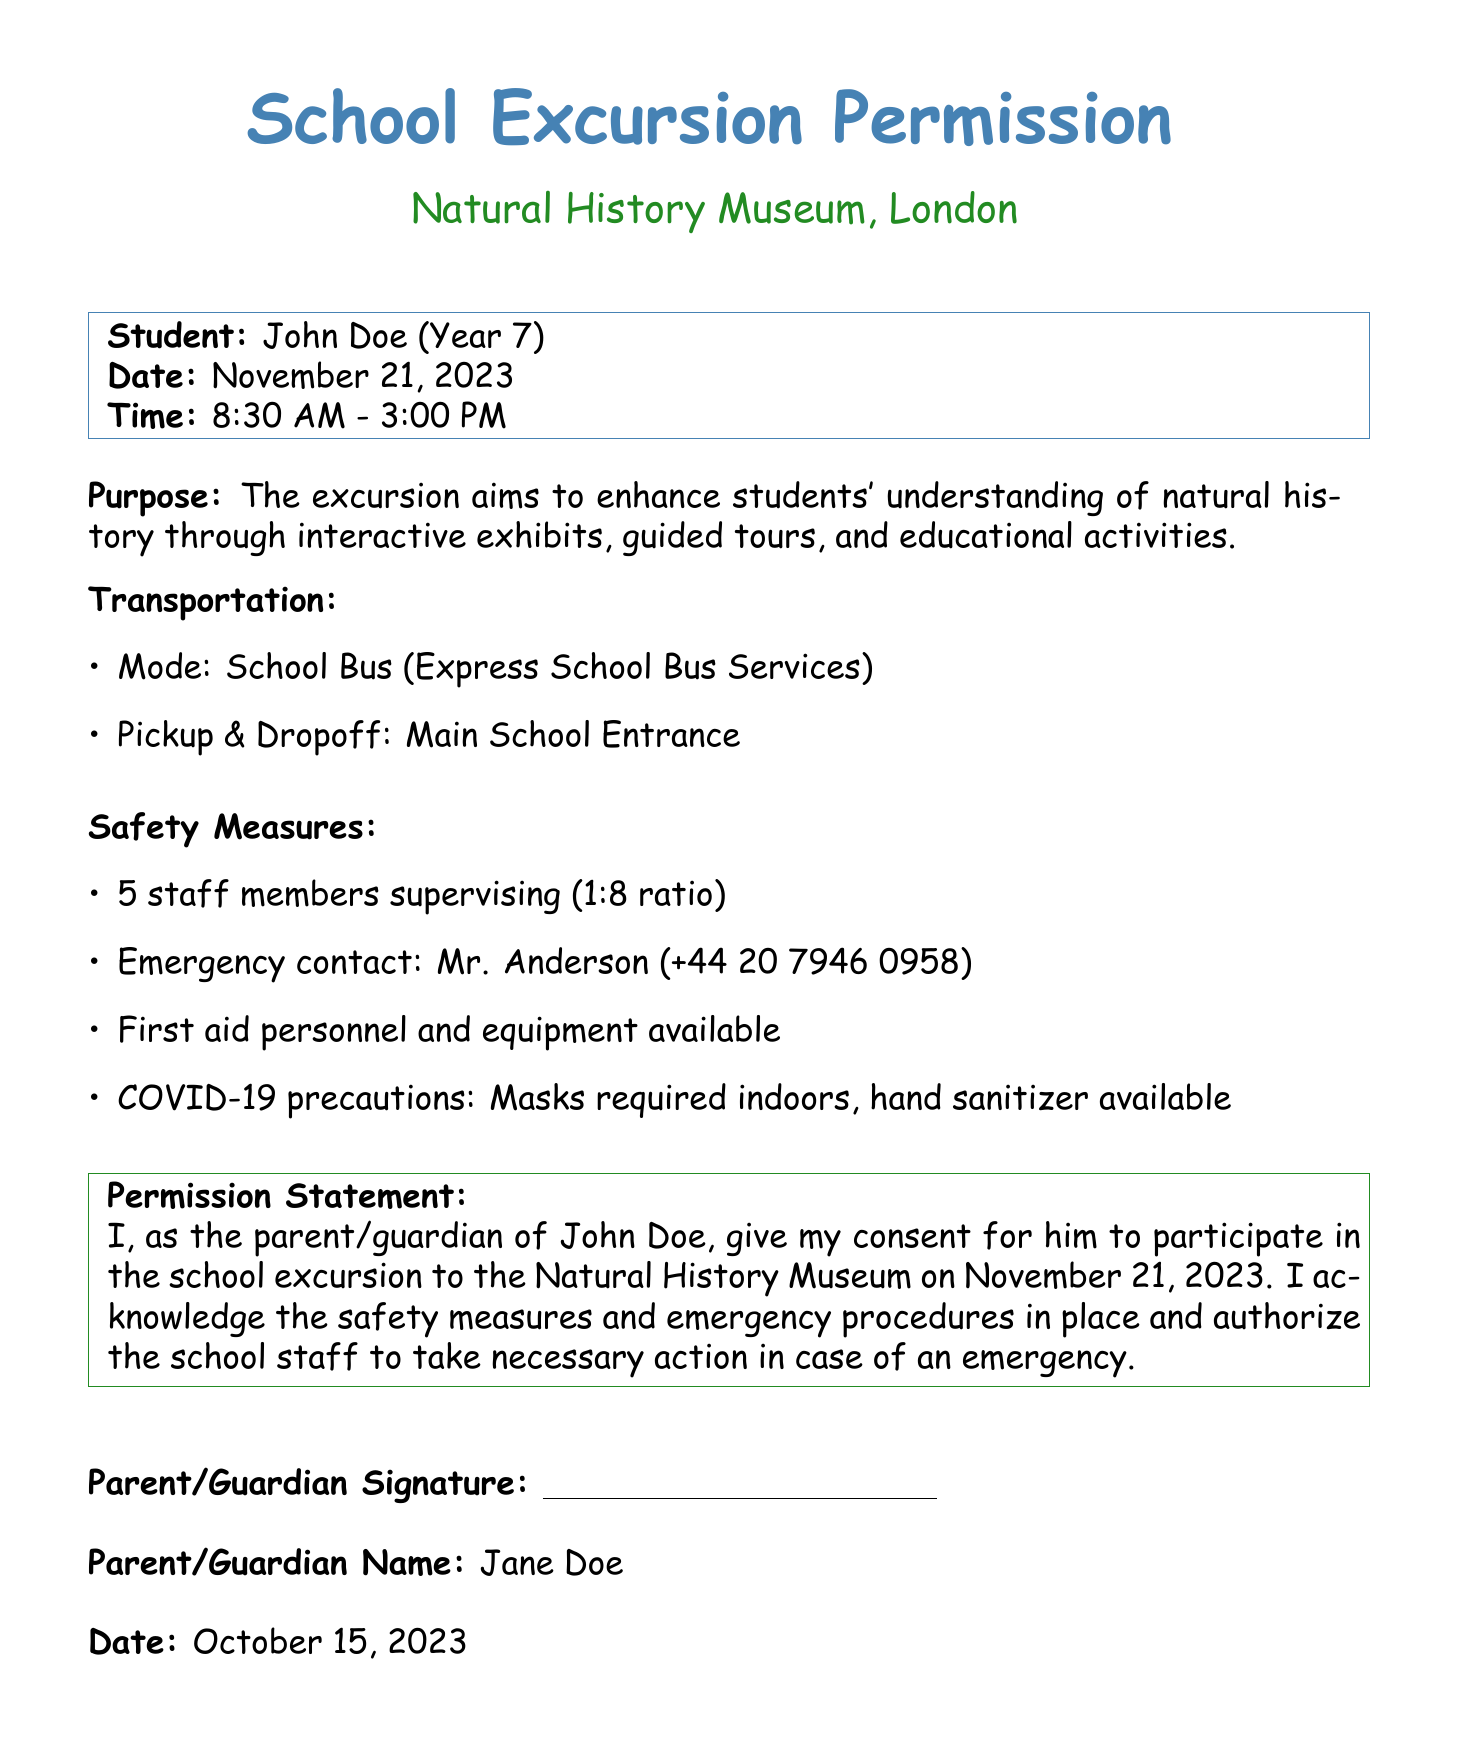What is the purpose of the excursion? The purpose is to enhance students' understanding of natural history through interactive exhibits, guided tours, and educational activities.
Answer: Enhance understanding of natural history What is the date of the school excursion? The date of the excursion is specified in the document.
Answer: November 21, 2023 Who is the emergency contact during the excursion? The document provides the name and contact information for the emergency contact.
Answer: Mr. Anderson What is the ratio of staff to students on this excursion? The document indicates there are 5 staff members supervising at a specific ratio.
Answer: 1:8 What are the COVID-19 precautions in place? The document lists the specific health measures that will be implemented during the excursion.
Answer: Masks required indoors, hand sanitizer available What mode of transportation will be used for the excursion? The transportation mode is clearly mentioned in the document.
Answer: School Bus How many students are supervised by one staff member? The supervision ratio indicates how many students each staff member oversees.
Answer: 8 students What is the signature line for? The signature line is meant for the parent/guardian confirming permission for the excursion.
Answer: Parent/Guardian Signature What equipment is available for emergencies? The safety measures detail the type of personnel and equipment available for emergencies.
Answer: First aid personnel and equipment 